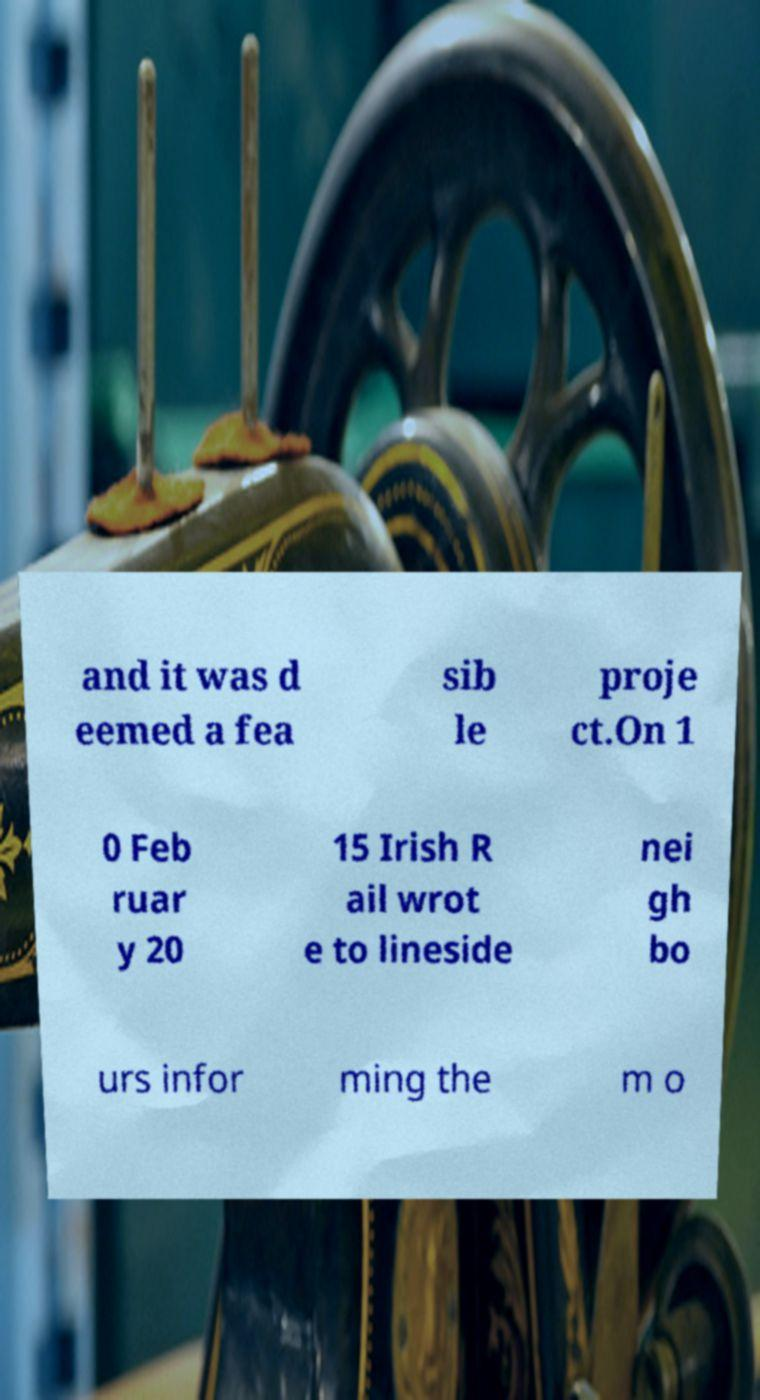Could you assist in decoding the text presented in this image and type it out clearly? and it was d eemed a fea sib le proje ct.On 1 0 Feb ruar y 20 15 Irish R ail wrot e to lineside nei gh bo urs infor ming the m o 